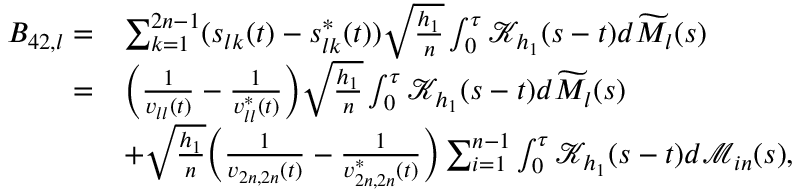Convert formula to latex. <formula><loc_0><loc_0><loc_500><loc_500>\begin{array} { r l } { B _ { 4 2 , l } = } & { \sum _ { k = 1 } ^ { 2 n - 1 } ( s _ { l k } ( t ) - s _ { l k } ^ { * } ( t ) ) \sqrt { \frac { h _ { 1 } } { n } } \int _ { 0 } ^ { \tau } \mathcal { K } _ { h _ { 1 } } ( s - t ) d \widetilde { M } _ { l } ( s ) } \\ { = } & { \left ( \frac { 1 } { v _ { l l } ( t ) } - \frac { 1 } { v _ { l l } ^ { * } ( t ) } \right ) \sqrt { \frac { h _ { 1 } } { n } } \int _ { 0 } ^ { \tau } \mathcal { K } _ { h _ { 1 } } ( s - t ) d \widetilde { M } _ { l } ( s ) } \\ & { + \sqrt { \frac { h _ { 1 } } { n } } \left ( \frac { 1 } { v _ { 2 n , 2 n } ( t ) } - \frac { 1 } { v _ { 2 n , 2 n } ^ { * } ( t ) } \right ) \sum _ { i = 1 } ^ { n - 1 } \int _ { 0 } ^ { \tau } \mathcal { K } _ { h _ { 1 } } ( s - t ) d \mathcal { M } _ { i n } ( s ) , } \end{array}</formula> 